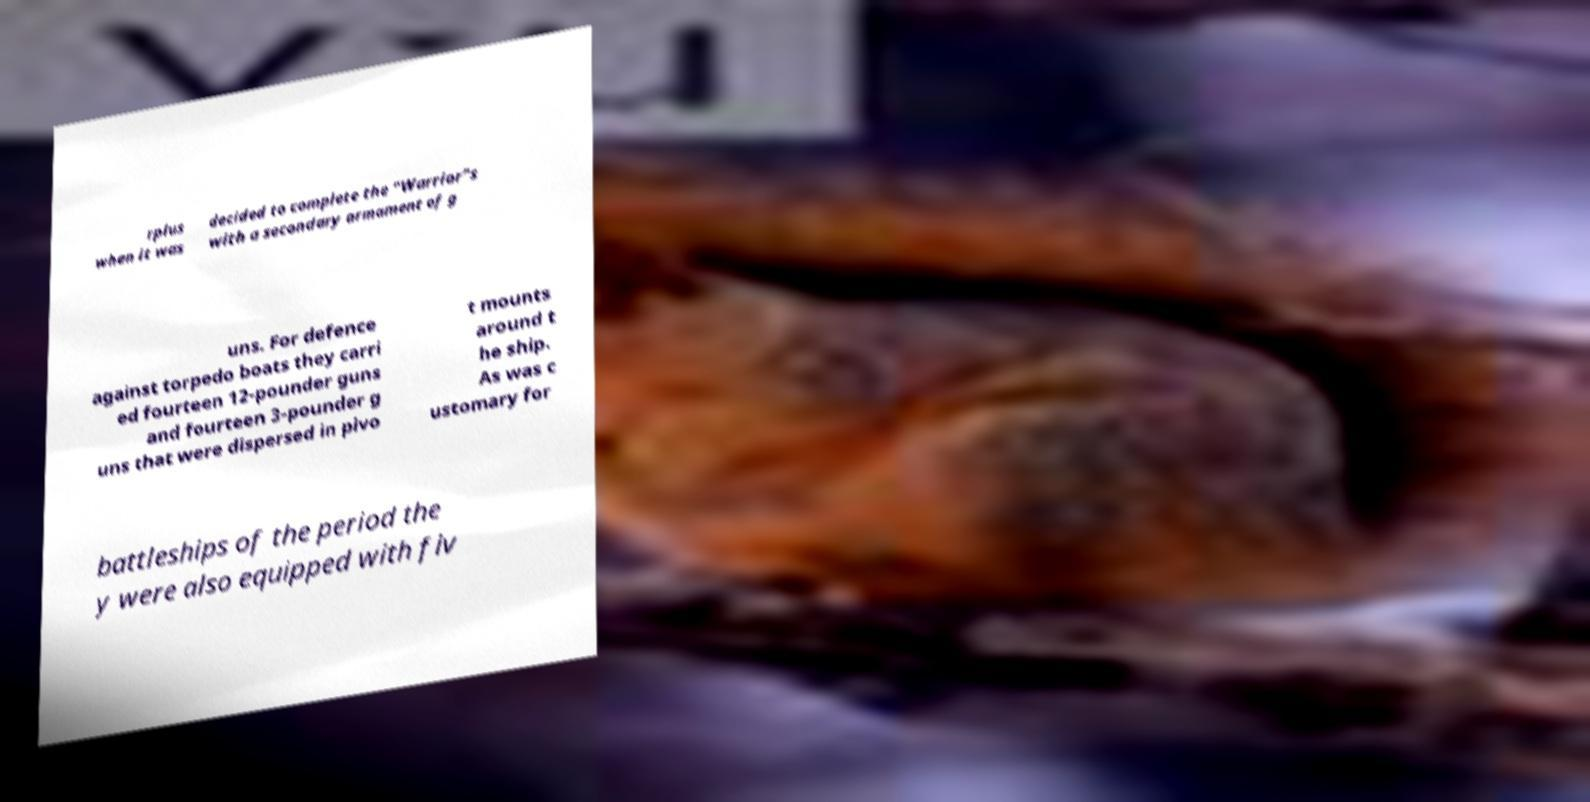Can you accurately transcribe the text from the provided image for me? rplus when it was decided to complete the "Warrior"s with a secondary armament of g uns. For defence against torpedo boats they carri ed fourteen 12-pounder guns and fourteen 3-pounder g uns that were dispersed in pivo t mounts around t he ship. As was c ustomary for battleships of the period the y were also equipped with fiv 